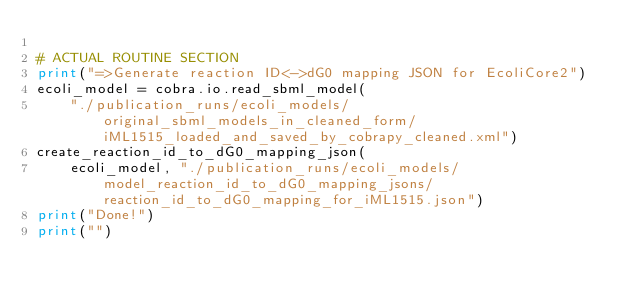<code> <loc_0><loc_0><loc_500><loc_500><_Python_>
# ACTUAL ROUTINE SECTION
print("=>Generate reaction ID<->dG0 mapping JSON for EcoliCore2")
ecoli_model = cobra.io.read_sbml_model(
    "./publication_runs/ecoli_models/original_sbml_models_in_cleaned_form/iML1515_loaded_and_saved_by_cobrapy_cleaned.xml")
create_reaction_id_to_dG0_mapping_json(
    ecoli_model, "./publication_runs/ecoli_models/model_reaction_id_to_dG0_mapping_jsons/reaction_id_to_dG0_mapping_for_iML1515.json")
print("Done!")
print("")
</code> 